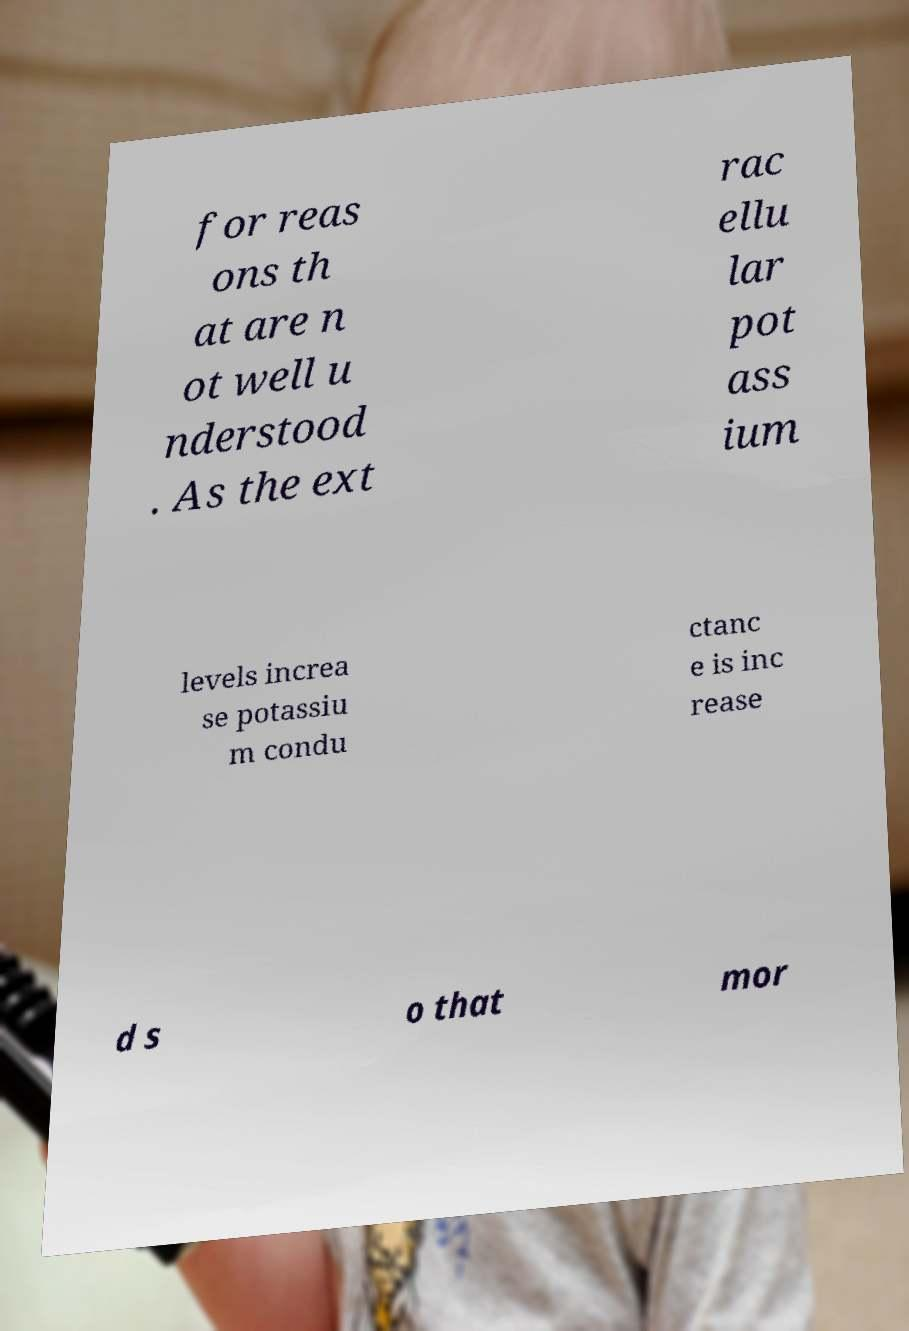There's text embedded in this image that I need extracted. Can you transcribe it verbatim? for reas ons th at are n ot well u nderstood . As the ext rac ellu lar pot ass ium levels increa se potassiu m condu ctanc e is inc rease d s o that mor 